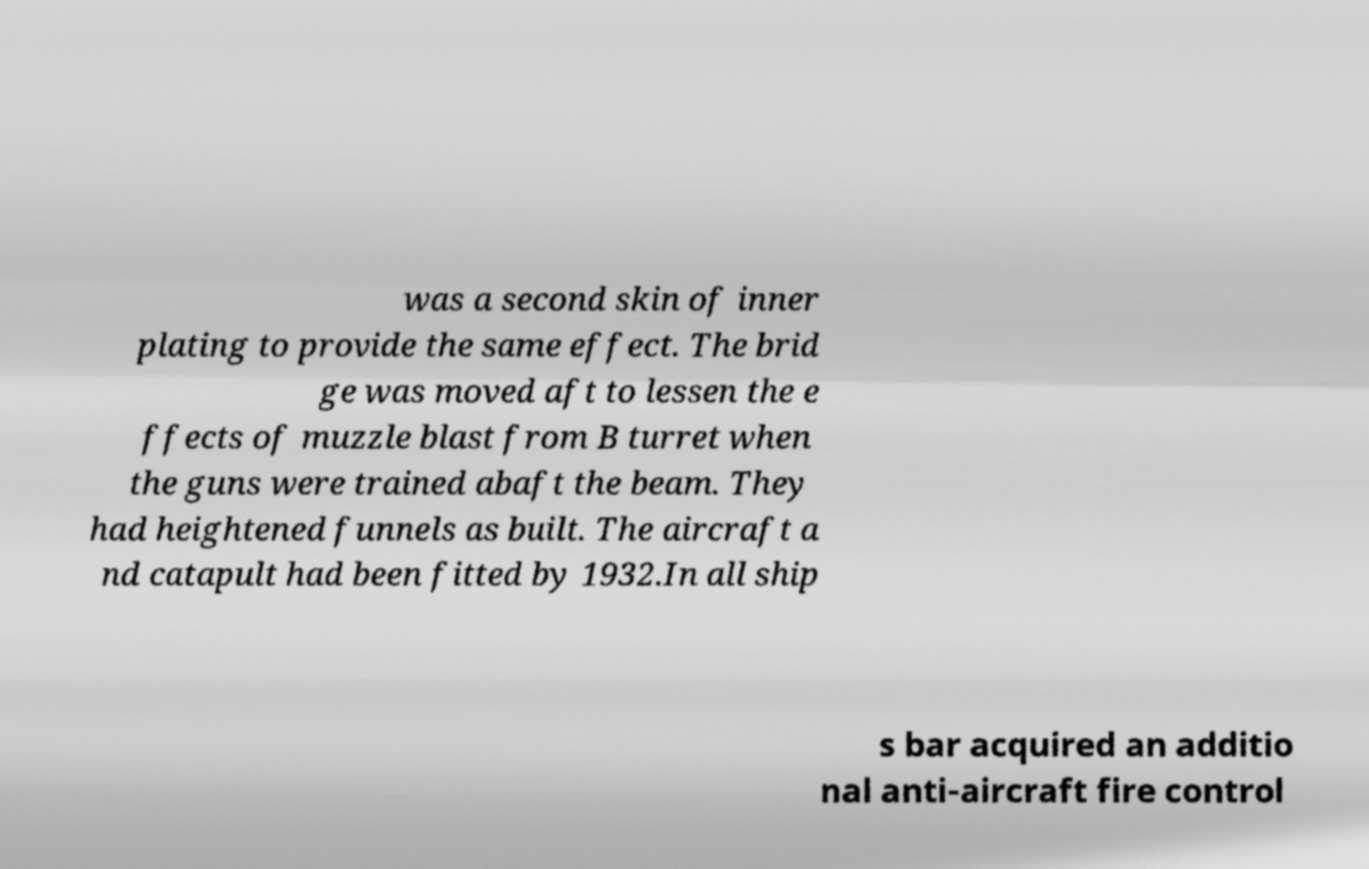Please identify and transcribe the text found in this image. was a second skin of inner plating to provide the same effect. The brid ge was moved aft to lessen the e ffects of muzzle blast from B turret when the guns were trained abaft the beam. They had heightened funnels as built. The aircraft a nd catapult had been fitted by 1932.In all ship s bar acquired an additio nal anti-aircraft fire control 